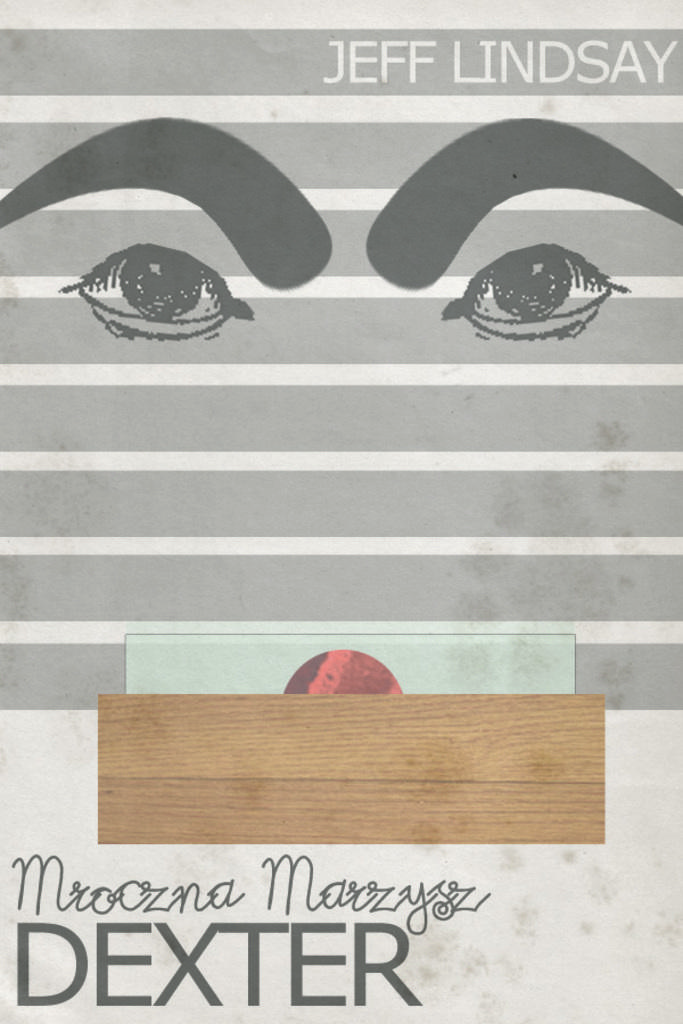What is present in the image that contains text? There is a poster in the image that has text written on it. Can you describe the poster in the image? The poster in the image has text written on it. What type of room is depicted in the poster? There is no room depicted in the poster; it only contains text. How many bricks are visible in the poster? There are no bricks present in the poster; it only contains text. 